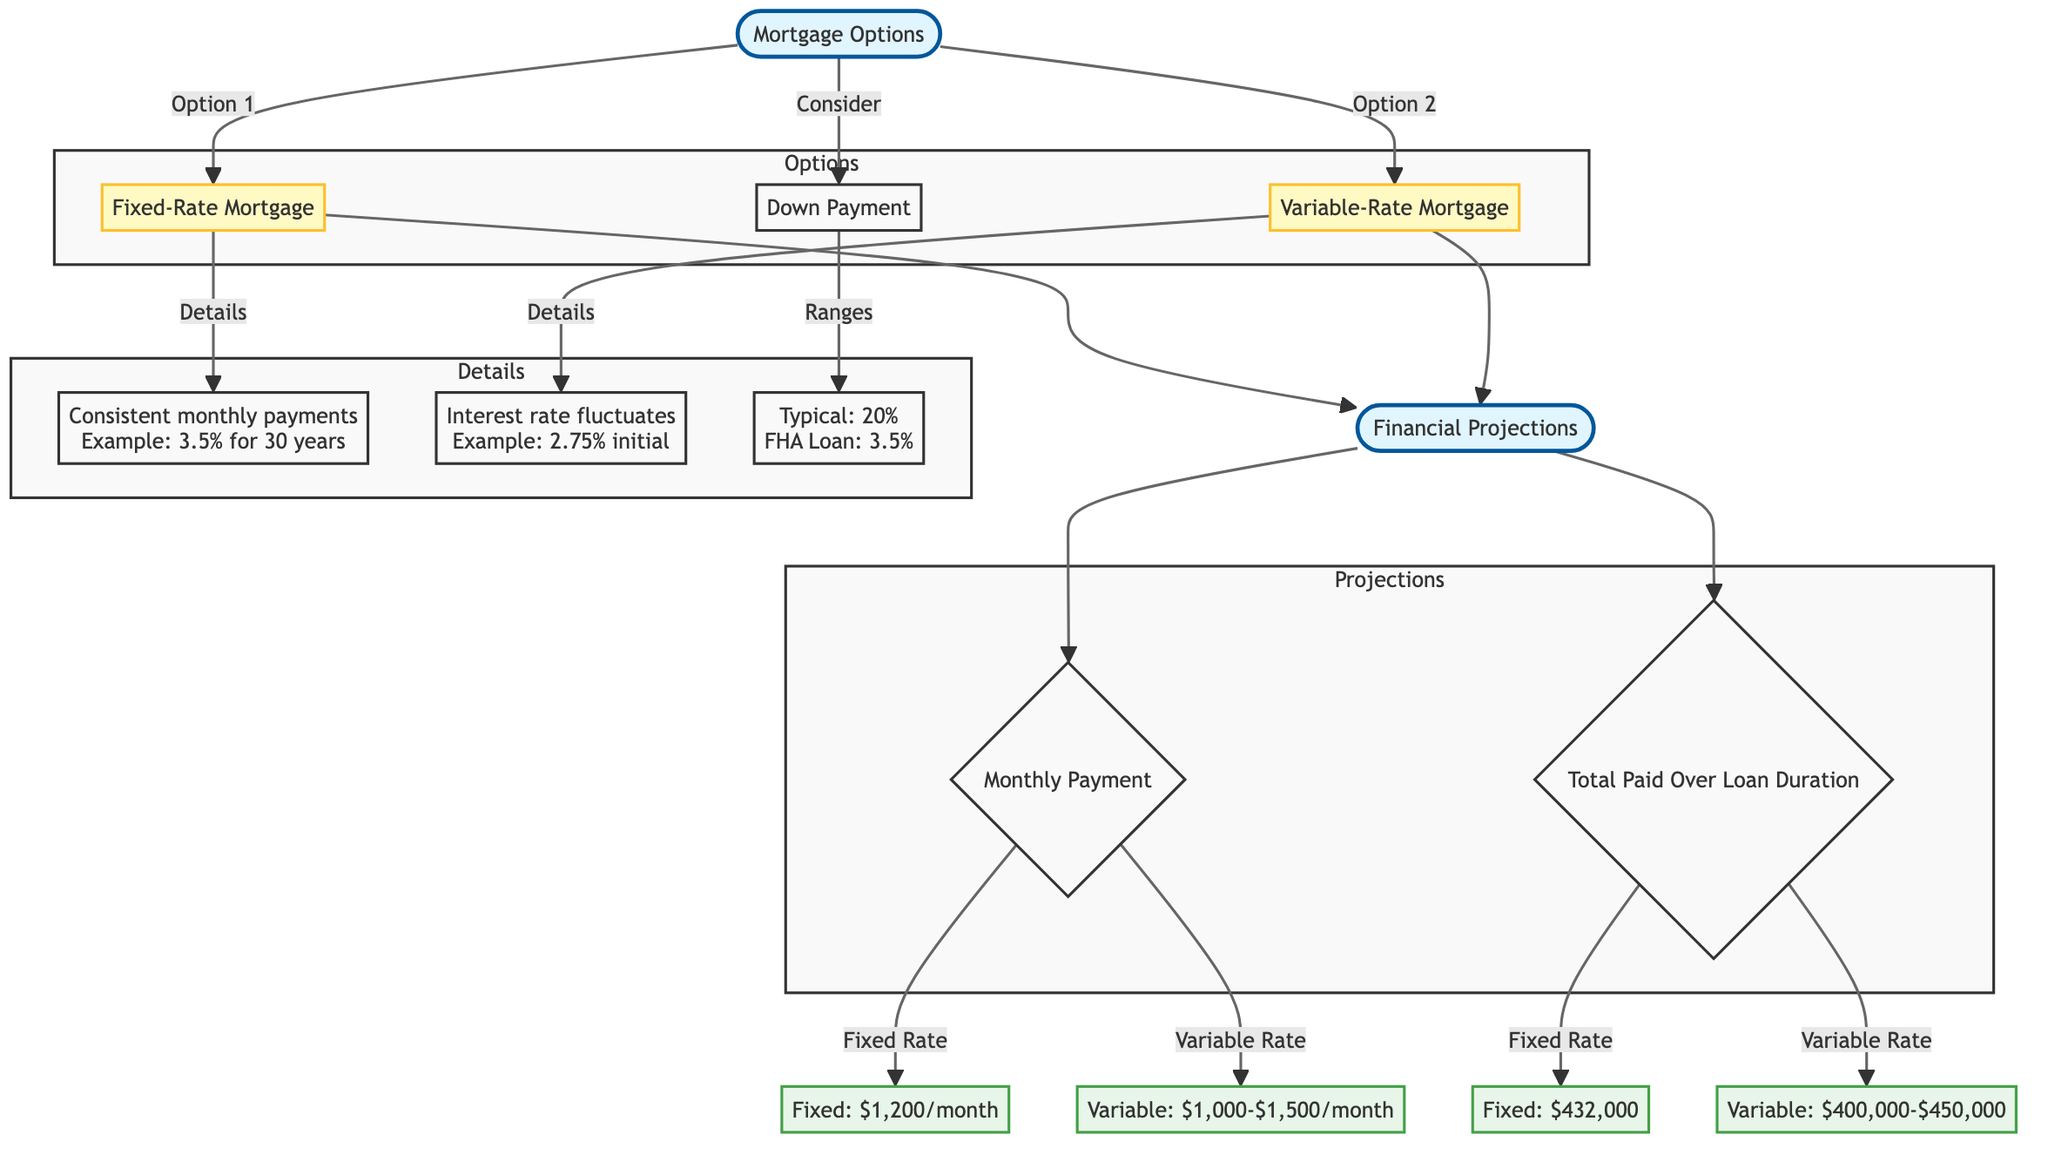What's the interest rate for a Fixed-Rate Mortgage? The diagram states that the fixed-rate mortgage has an example interest rate of 3.5%. This information is directly described in the node labeled "Fixed-Rate Mortgage".
Answer: 3.5% What is the typical down payment percentage for a mortgage? According to the diagram, the typical down payment percentage is listed as 20% in the "Down Payment" section.
Answer: 20% Which option has a consistent monthly payment? The diagram indicates that the Fixed-Rate Mortgage is the option with consistent monthly payments, as detailed under "Fixed-Rate Mortgage".
Answer: Fixed-Rate Mortgage What is the total paid for a Fixed-Rate Mortgage over the loan duration? The diagram shows the total paid over the duration of a Fixed-Rate Mortgage is $432,000, which is indicated in the "Total Paid Over Loan Duration" section for this mortgage type.
Answer: $432,000 What range is given for the monthly payment of a Variable-Rate Mortgage? The diagram specifies that the monthly payment for a Variable-Rate Mortgage ranges from $1,000 to $1,500. This detail is found in the "Monthly Payment" section under the variable rate option.
Answer: $1,000-$1,500 What are the three down payment percentages mentioned in the diagram? The diagram mentions two down payment percentages: 20% as typical for loans and 3.5% specifically for FHA loans. This information is captured in the "Down Payment" node.
Answer: 20%, 3.5% Which mortgage option has potential fluctuations in monthly payments? The diagram identifies the Variable-Rate Mortgage as the option that has fluctuations due to its interest rate changing over time, highlighted in the "Variable-Rate Mortgage" section.
Answer: Variable-Rate Mortgage How does the total paid for a Variable-Rate Mortgage compare to the Fixed-Rate Mortgage? The diagram shows that the total paid for a Variable-Rate Mortgage is between $400,000 and $450,000, which is less than the total of $432,000 paid for a Fixed-Rate Mortgage. Therefore, the total for the Fixed-Rate Mortgage is higher than that of the Variable-Rate Mortgage.
Answer: Higher than Variable-Rate Mortgage 